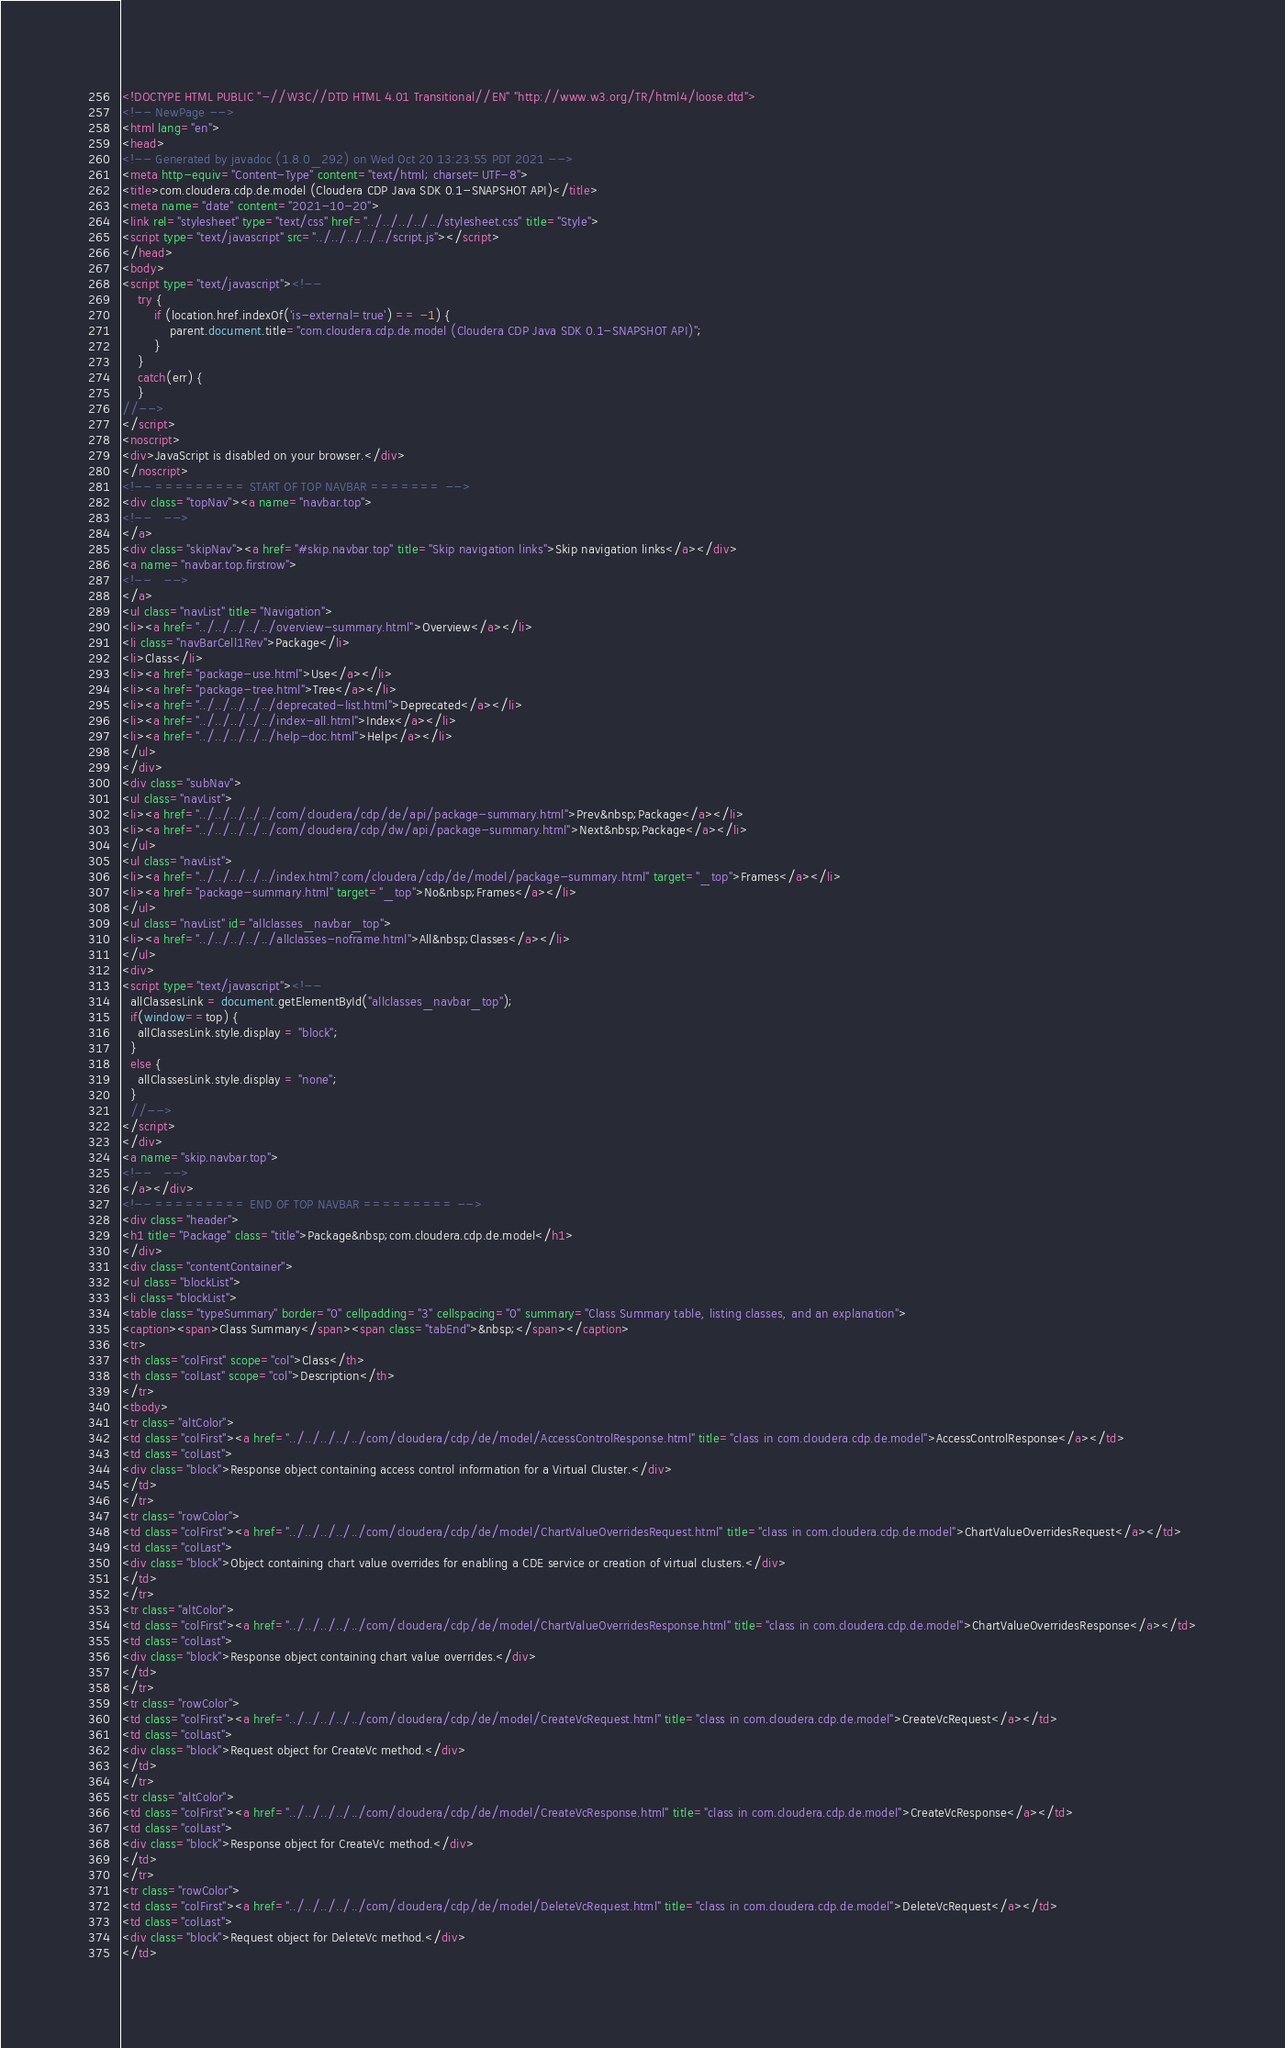<code> <loc_0><loc_0><loc_500><loc_500><_HTML_><!DOCTYPE HTML PUBLIC "-//W3C//DTD HTML 4.01 Transitional//EN" "http://www.w3.org/TR/html4/loose.dtd">
<!-- NewPage -->
<html lang="en">
<head>
<!-- Generated by javadoc (1.8.0_292) on Wed Oct 20 13:23:55 PDT 2021 -->
<meta http-equiv="Content-Type" content="text/html; charset=UTF-8">
<title>com.cloudera.cdp.de.model (Cloudera CDP Java SDK 0.1-SNAPSHOT API)</title>
<meta name="date" content="2021-10-20">
<link rel="stylesheet" type="text/css" href="../../../../../stylesheet.css" title="Style">
<script type="text/javascript" src="../../../../../script.js"></script>
</head>
<body>
<script type="text/javascript"><!--
    try {
        if (location.href.indexOf('is-external=true') == -1) {
            parent.document.title="com.cloudera.cdp.de.model (Cloudera CDP Java SDK 0.1-SNAPSHOT API)";
        }
    }
    catch(err) {
    }
//-->
</script>
<noscript>
<div>JavaScript is disabled on your browser.</div>
</noscript>
<!-- ========= START OF TOP NAVBAR ======= -->
<div class="topNav"><a name="navbar.top">
<!--   -->
</a>
<div class="skipNav"><a href="#skip.navbar.top" title="Skip navigation links">Skip navigation links</a></div>
<a name="navbar.top.firstrow">
<!--   -->
</a>
<ul class="navList" title="Navigation">
<li><a href="../../../../../overview-summary.html">Overview</a></li>
<li class="navBarCell1Rev">Package</li>
<li>Class</li>
<li><a href="package-use.html">Use</a></li>
<li><a href="package-tree.html">Tree</a></li>
<li><a href="../../../../../deprecated-list.html">Deprecated</a></li>
<li><a href="../../../../../index-all.html">Index</a></li>
<li><a href="../../../../../help-doc.html">Help</a></li>
</ul>
</div>
<div class="subNav">
<ul class="navList">
<li><a href="../../../../../com/cloudera/cdp/de/api/package-summary.html">Prev&nbsp;Package</a></li>
<li><a href="../../../../../com/cloudera/cdp/dw/api/package-summary.html">Next&nbsp;Package</a></li>
</ul>
<ul class="navList">
<li><a href="../../../../../index.html?com/cloudera/cdp/de/model/package-summary.html" target="_top">Frames</a></li>
<li><a href="package-summary.html" target="_top">No&nbsp;Frames</a></li>
</ul>
<ul class="navList" id="allclasses_navbar_top">
<li><a href="../../../../../allclasses-noframe.html">All&nbsp;Classes</a></li>
</ul>
<div>
<script type="text/javascript"><!--
  allClassesLink = document.getElementById("allclasses_navbar_top");
  if(window==top) {
    allClassesLink.style.display = "block";
  }
  else {
    allClassesLink.style.display = "none";
  }
  //-->
</script>
</div>
<a name="skip.navbar.top">
<!--   -->
</a></div>
<!-- ========= END OF TOP NAVBAR ========= -->
<div class="header">
<h1 title="Package" class="title">Package&nbsp;com.cloudera.cdp.de.model</h1>
</div>
<div class="contentContainer">
<ul class="blockList">
<li class="blockList">
<table class="typeSummary" border="0" cellpadding="3" cellspacing="0" summary="Class Summary table, listing classes, and an explanation">
<caption><span>Class Summary</span><span class="tabEnd">&nbsp;</span></caption>
<tr>
<th class="colFirst" scope="col">Class</th>
<th class="colLast" scope="col">Description</th>
</tr>
<tbody>
<tr class="altColor">
<td class="colFirst"><a href="../../../../../com/cloudera/cdp/de/model/AccessControlResponse.html" title="class in com.cloudera.cdp.de.model">AccessControlResponse</a></td>
<td class="colLast">
<div class="block">Response object containing access control information for a Virtual Cluster.</div>
</td>
</tr>
<tr class="rowColor">
<td class="colFirst"><a href="../../../../../com/cloudera/cdp/de/model/ChartValueOverridesRequest.html" title="class in com.cloudera.cdp.de.model">ChartValueOverridesRequest</a></td>
<td class="colLast">
<div class="block">Object containing chart value overrides for enabling a CDE service or creation of virtual clusters.</div>
</td>
</tr>
<tr class="altColor">
<td class="colFirst"><a href="../../../../../com/cloudera/cdp/de/model/ChartValueOverridesResponse.html" title="class in com.cloudera.cdp.de.model">ChartValueOverridesResponse</a></td>
<td class="colLast">
<div class="block">Response object containing chart value overrides.</div>
</td>
</tr>
<tr class="rowColor">
<td class="colFirst"><a href="../../../../../com/cloudera/cdp/de/model/CreateVcRequest.html" title="class in com.cloudera.cdp.de.model">CreateVcRequest</a></td>
<td class="colLast">
<div class="block">Request object for CreateVc method.</div>
</td>
</tr>
<tr class="altColor">
<td class="colFirst"><a href="../../../../../com/cloudera/cdp/de/model/CreateVcResponse.html" title="class in com.cloudera.cdp.de.model">CreateVcResponse</a></td>
<td class="colLast">
<div class="block">Response object for CreateVc method.</div>
</td>
</tr>
<tr class="rowColor">
<td class="colFirst"><a href="../../../../../com/cloudera/cdp/de/model/DeleteVcRequest.html" title="class in com.cloudera.cdp.de.model">DeleteVcRequest</a></td>
<td class="colLast">
<div class="block">Request object for DeleteVc method.</div>
</td></code> 